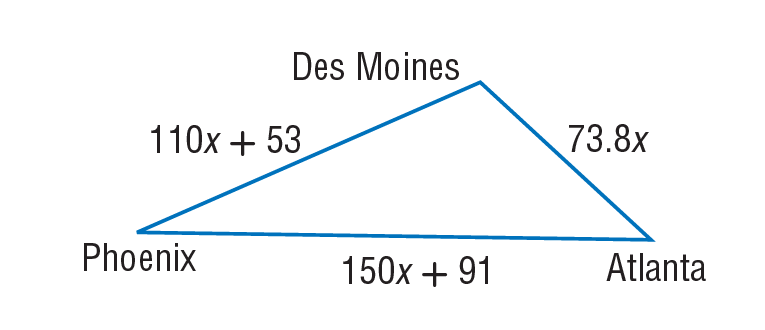Answer the mathemtical geometry problem and directly provide the correct option letter.
Question: A plane travels from Des Moines to Phoenix, on to Atlanta, and back to Des Moines, as shown below. Find the distance in miles from Des Moines to Phoenix if the total trip was 3482 miles.
Choices: A: 73.8 B: 91 C: 110 D: 1153 D 